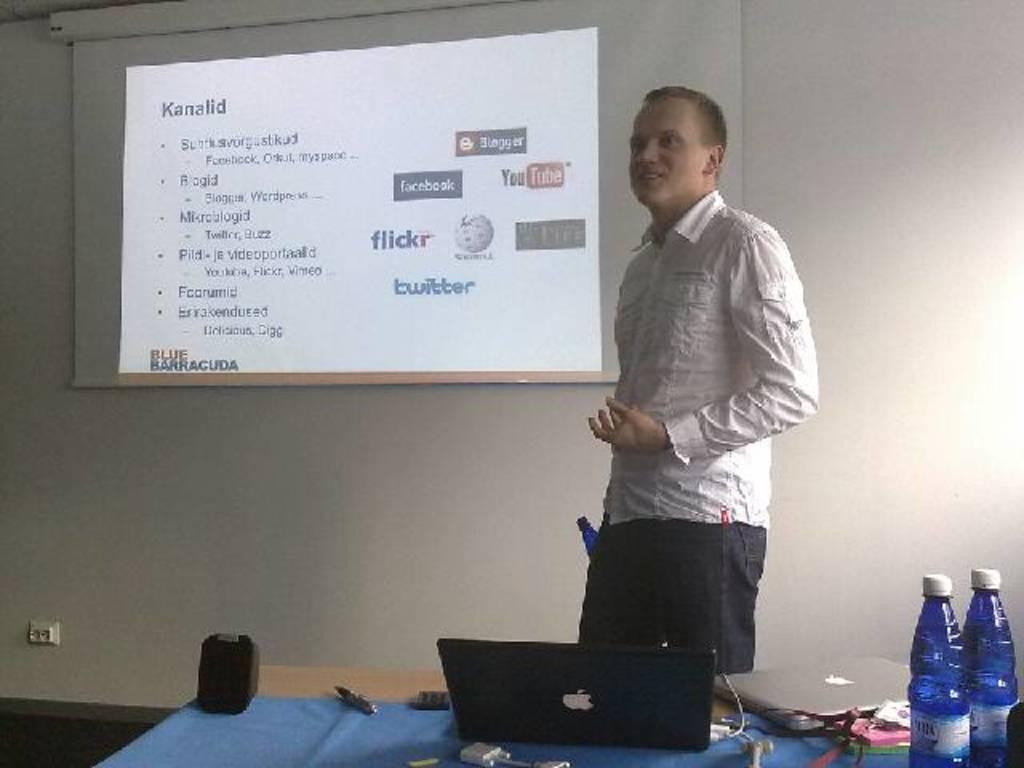What is the person in the image doing? The person is standing near a wall in the image. What is on the wall in the image? There is a screen and a laptop on the wall. Are there any other objects on the wall? Yes, there are bottles on the wall. What type of rhythm does the scarecrow have in the image? There is no scarecrow present in the image, so it is not possible to determine its rhythm. 